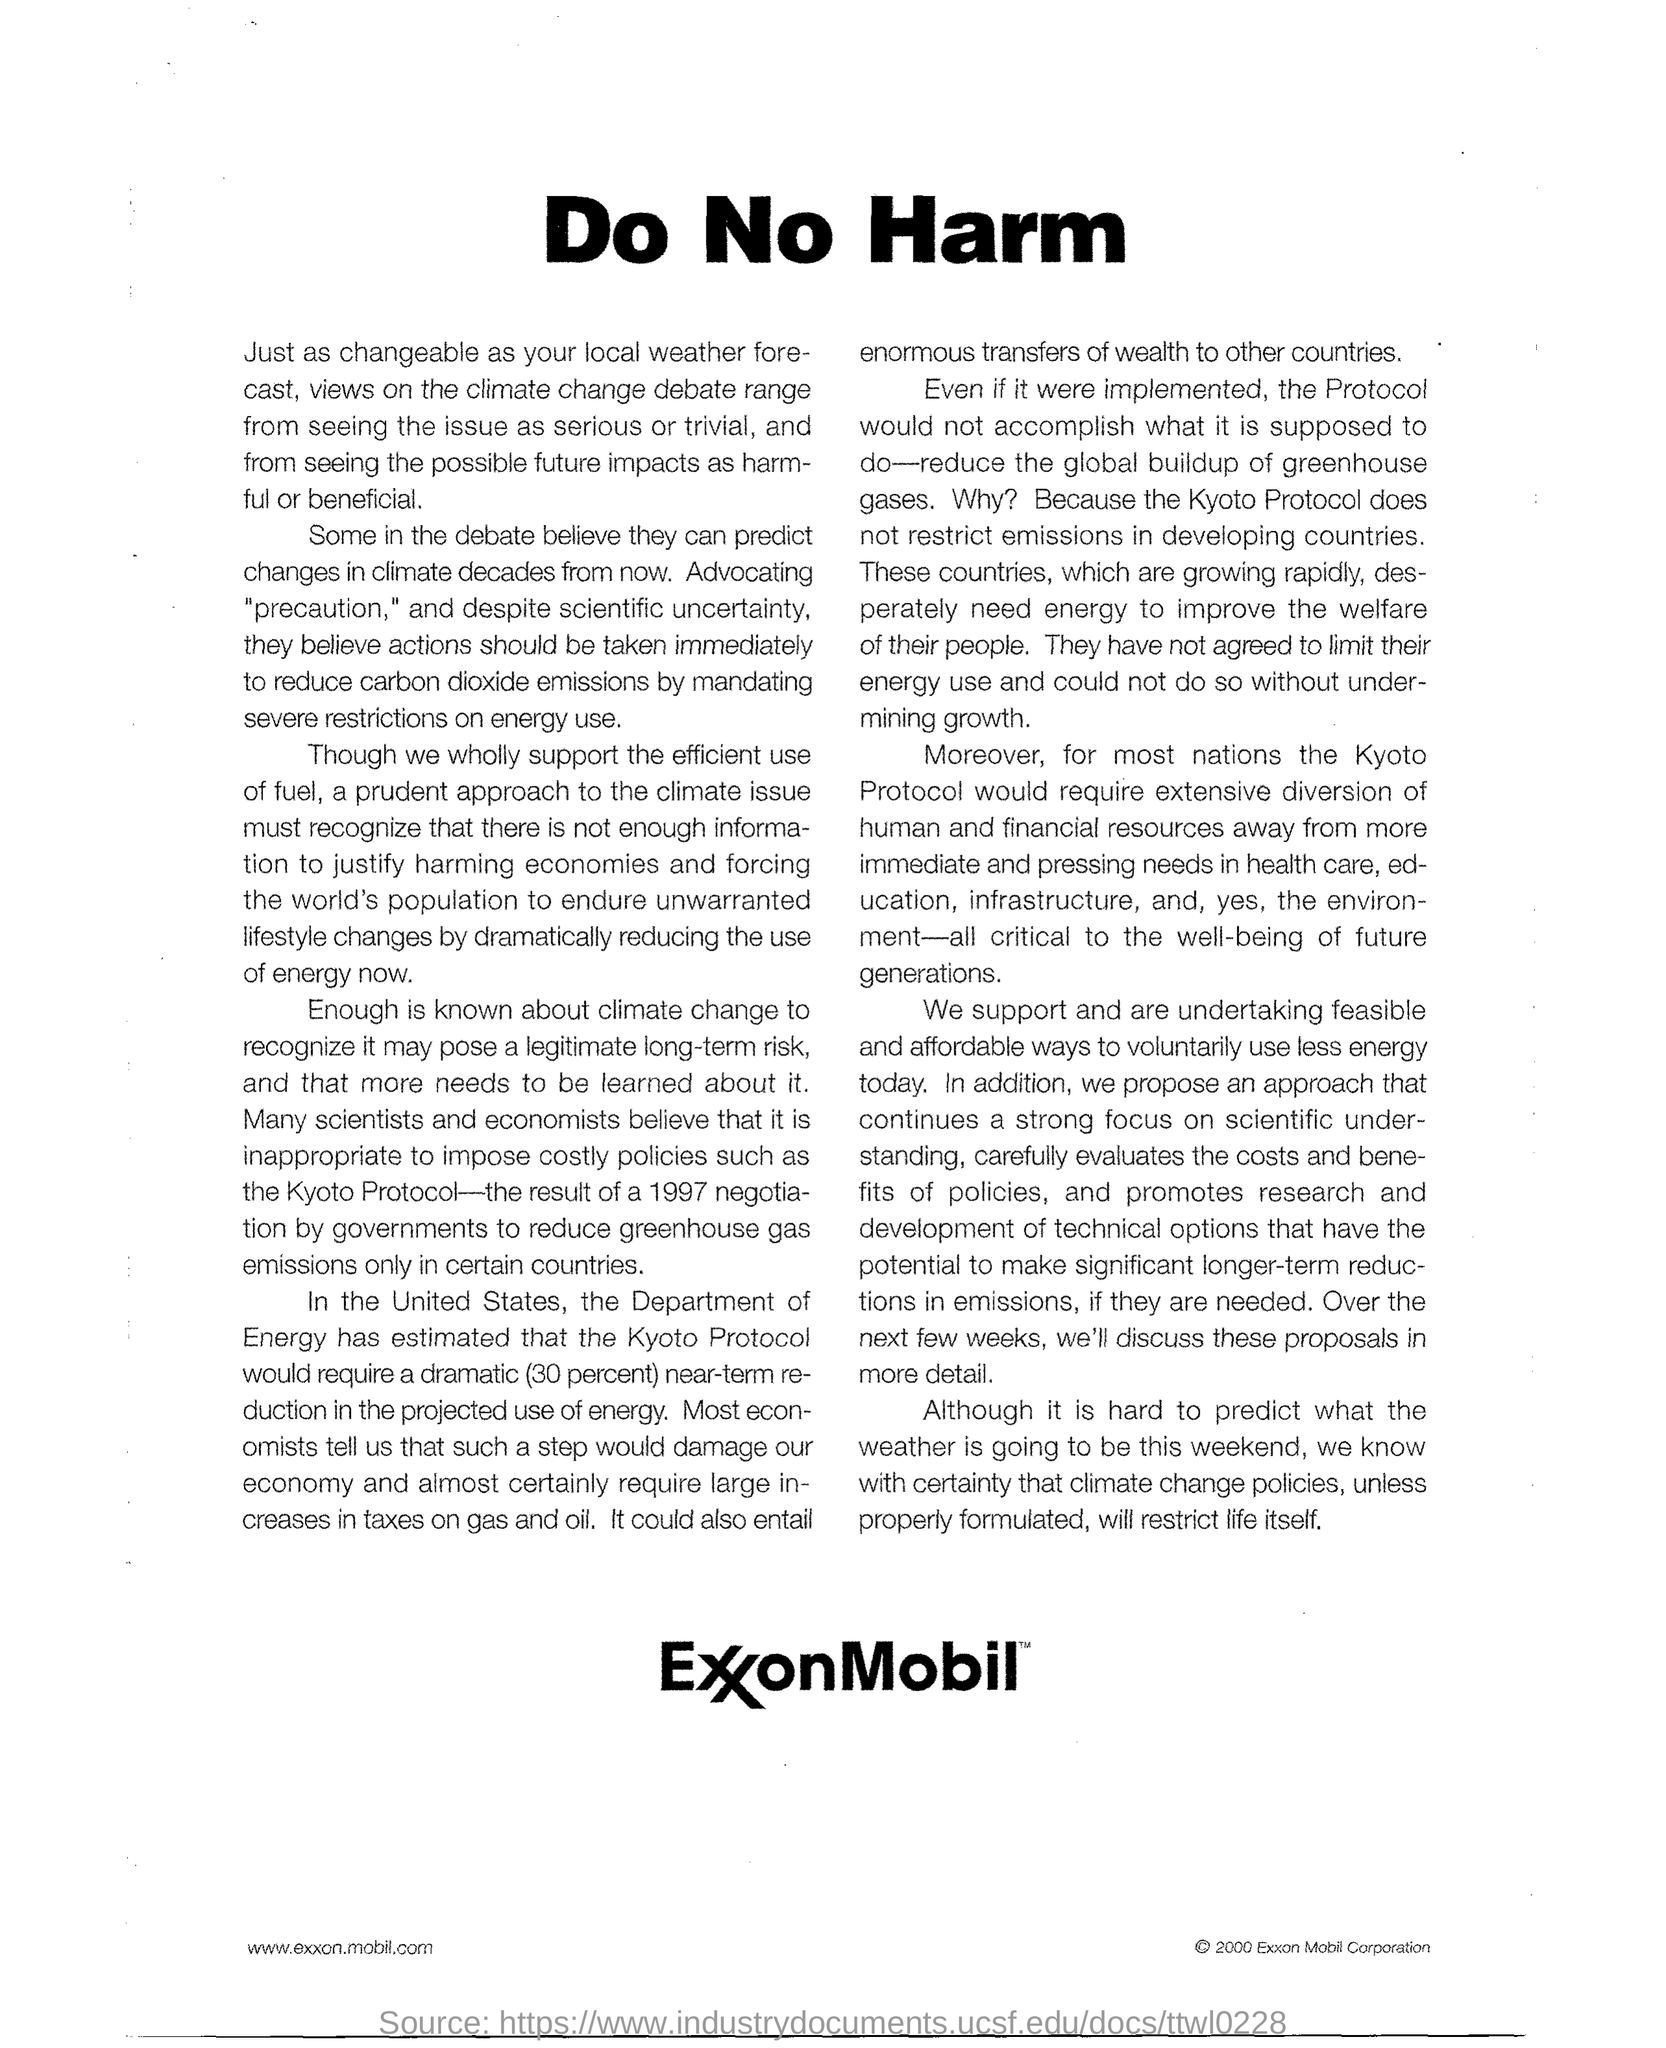Point out several critical features in this image. The government in certain countries imposed the Kyoto Protocol, which is a protocol that aims to reduce greenhouse gas emissions. 